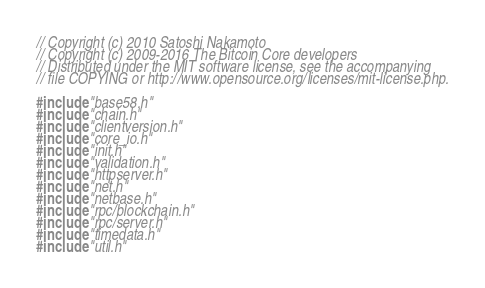<code> <loc_0><loc_0><loc_500><loc_500><_C++_>// Copyright (c) 2010 Satoshi Nakamoto
// Copyright (c) 2009-2016 The Bitcoin Core developers
// Distributed under the MIT software license, see the accompanying
// file COPYING or http://www.opensource.org/licenses/mit-license.php.

#include "base58.h"
#include "chain.h"
#include "clientversion.h"
#include "core_io.h"
#include "init.h"
#include "validation.h"
#include "httpserver.h"
#include "net.h"
#include "netbase.h"
#include "rpc/blockchain.h"
#include "rpc/server.h"
#include "timedata.h"
#include "util.h"</code> 